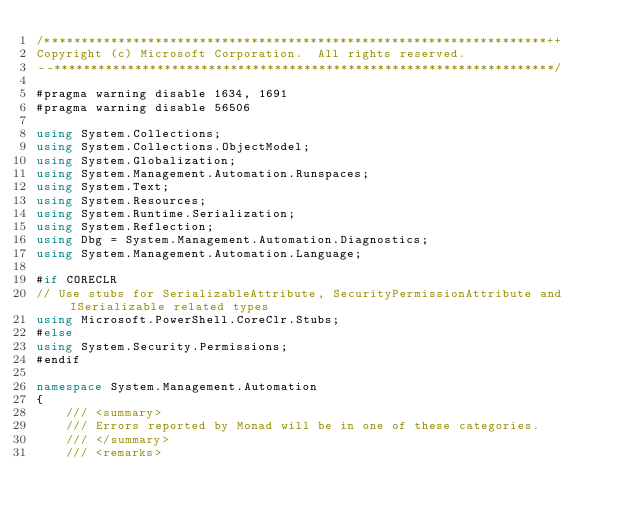Convert code to text. <code><loc_0><loc_0><loc_500><loc_500><_C#_>/********************************************************************++
Copyright (c) Microsoft Corporation.  All rights reserved.
--********************************************************************/

#pragma warning disable 1634, 1691
#pragma warning disable 56506

using System.Collections;
using System.Collections.ObjectModel;
using System.Globalization;
using System.Management.Automation.Runspaces;
using System.Text;
using System.Resources;
using System.Runtime.Serialization;
using System.Reflection;
using Dbg = System.Management.Automation.Diagnostics;
using System.Management.Automation.Language;

#if CORECLR
// Use stubs for SerializableAttribute, SecurityPermissionAttribute and ISerializable related types
using Microsoft.PowerShell.CoreClr.Stubs;
#else
using System.Security.Permissions;
#endif

namespace System.Management.Automation
{
    /// <summary>
    /// Errors reported by Monad will be in one of these categories.
    /// </summary>
    /// <remarks></code> 